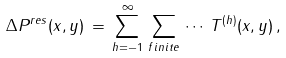<formula> <loc_0><loc_0><loc_500><loc_500>\Delta P ^ { r e s } ( x , y ) \, = \, \sum _ { h = - 1 } ^ { \infty } \, \sum _ { f i n i t e } \, \cdots \, T ^ { ( h ) } ( x , y ) \, ,</formula> 